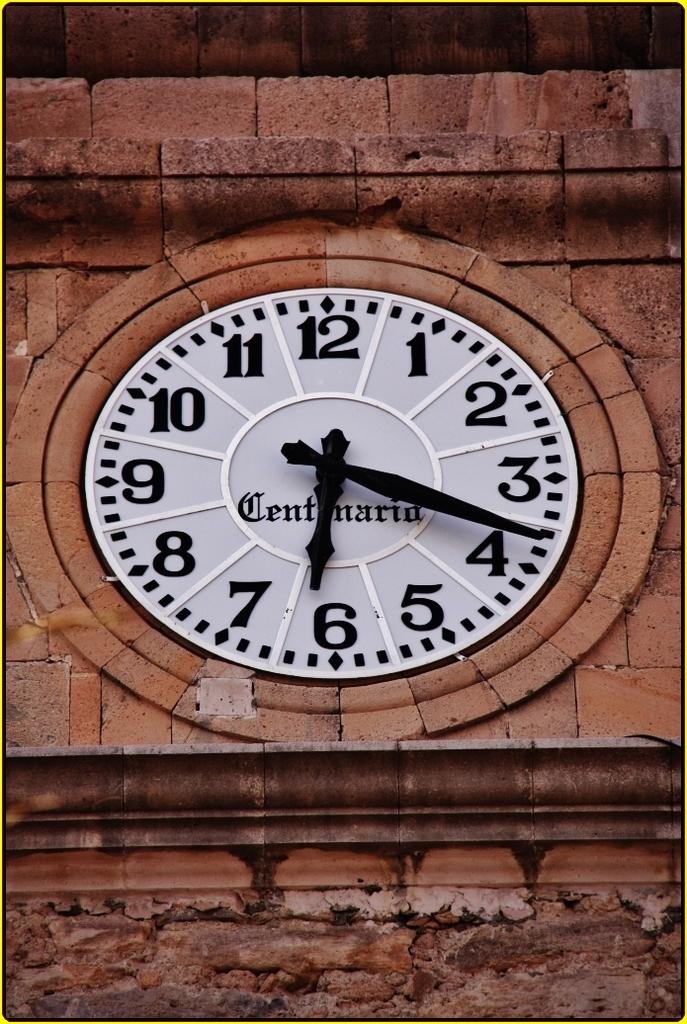What's the brand of the clock in the middle, behind the dials?
Provide a short and direct response. Centmaria. 